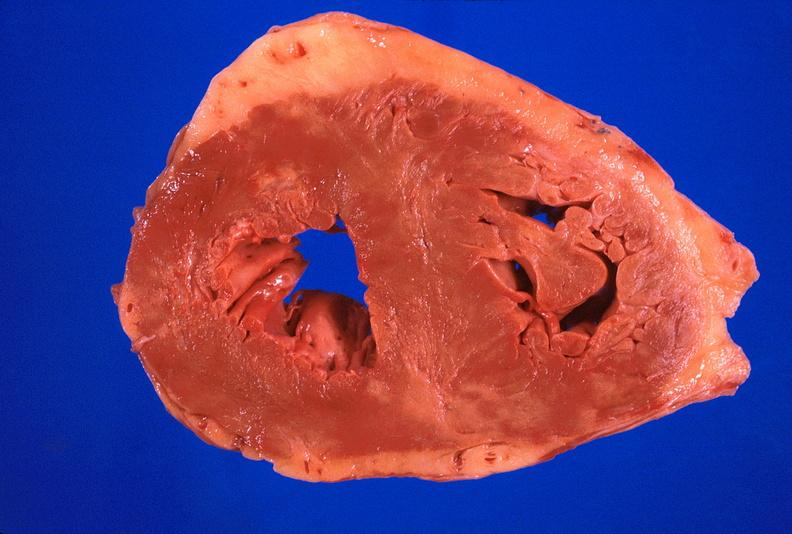what is present?
Answer the question using a single word or phrase. Cardiovascular 